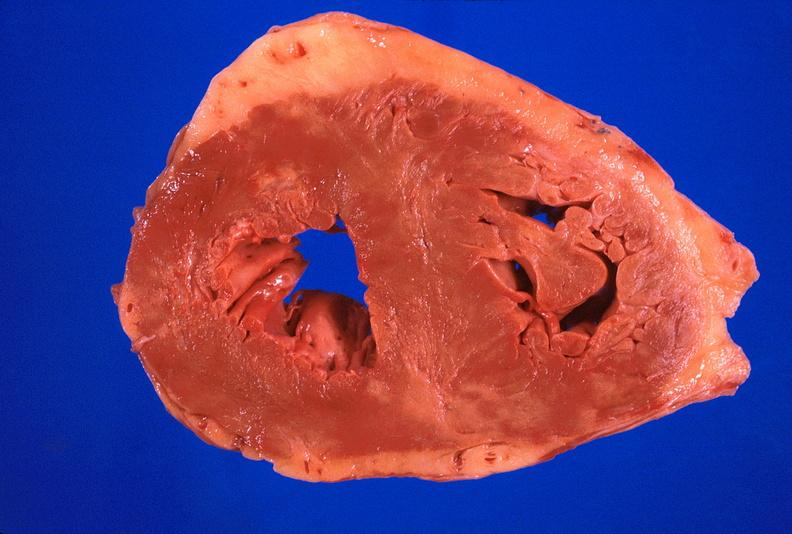what is present?
Answer the question using a single word or phrase. Cardiovascular 